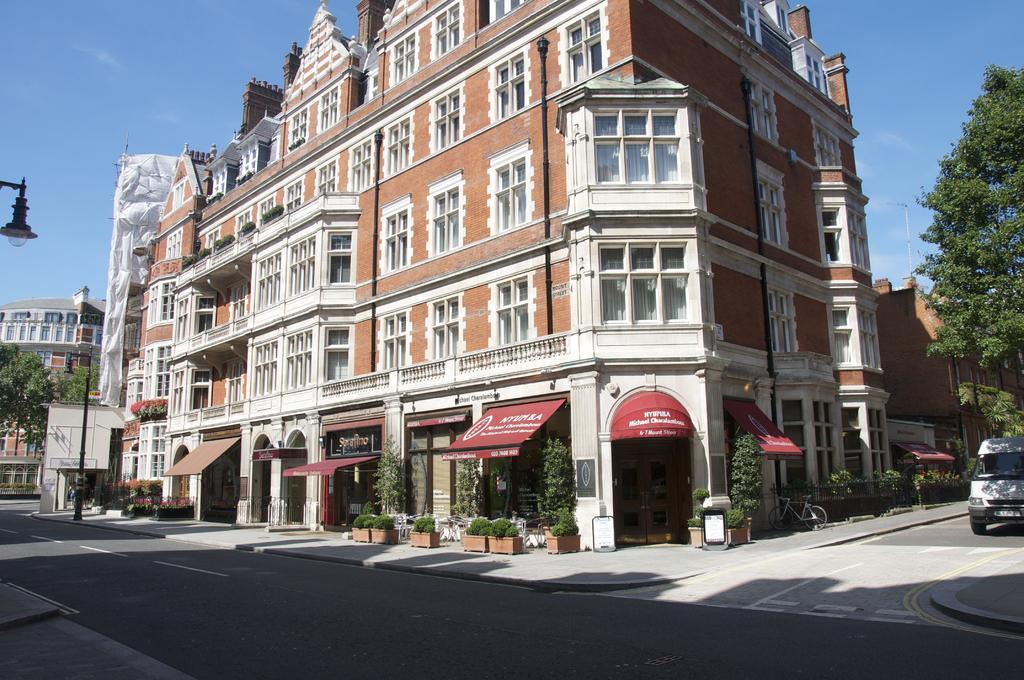Could you give a brief overview of what you see in this image? In this image I can see a building in brown color. I can also see few stalls, background I can see trees in green color, vehicles, few light poles and sky in blue color. 